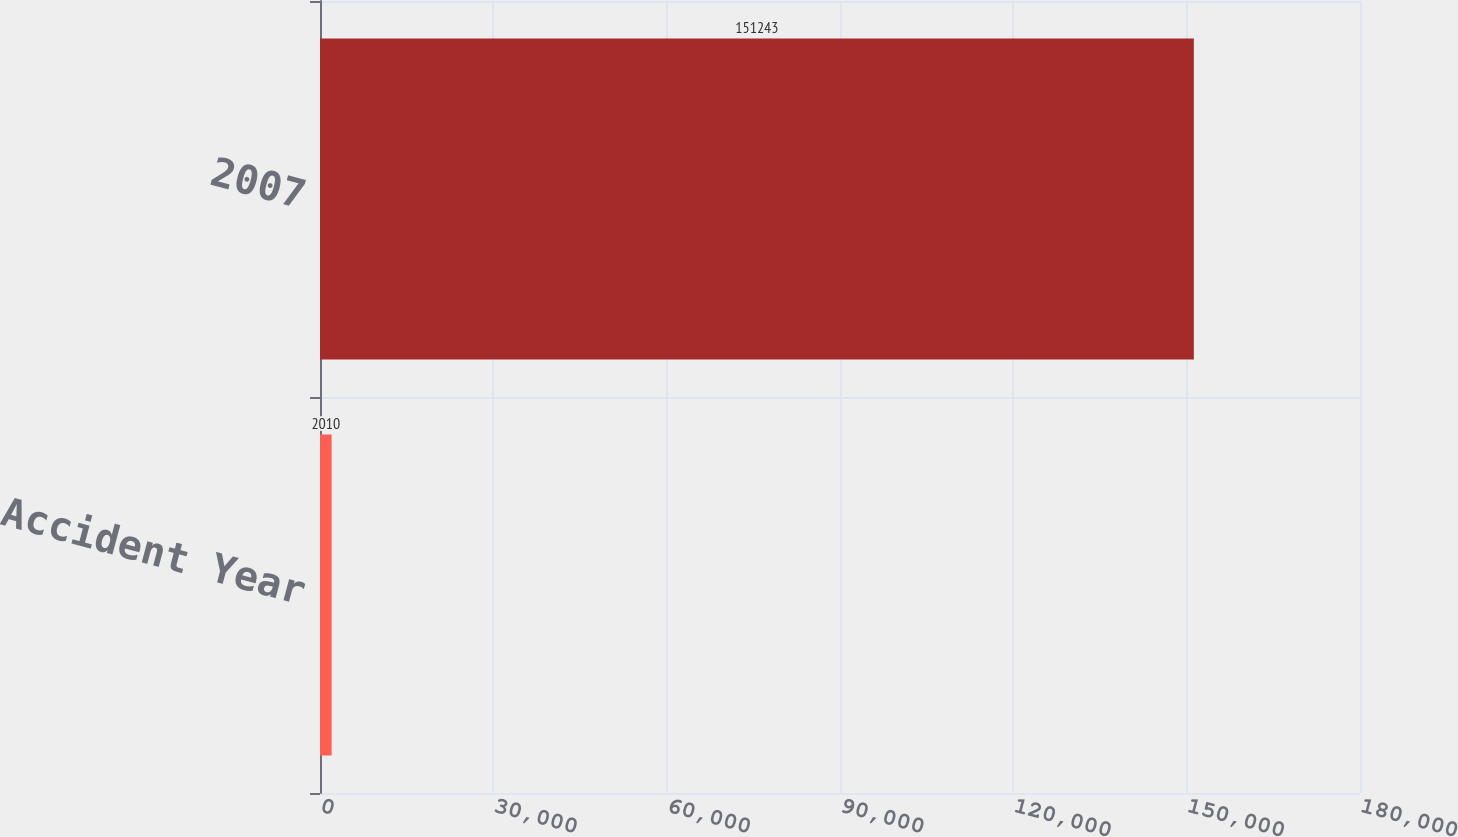Convert chart to OTSL. <chart><loc_0><loc_0><loc_500><loc_500><bar_chart><fcel>Accident Year<fcel>2007<nl><fcel>2010<fcel>151243<nl></chart> 